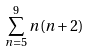Convert formula to latex. <formula><loc_0><loc_0><loc_500><loc_500>\sum _ { n = 5 } ^ { 9 } n ( n + 2 )</formula> 